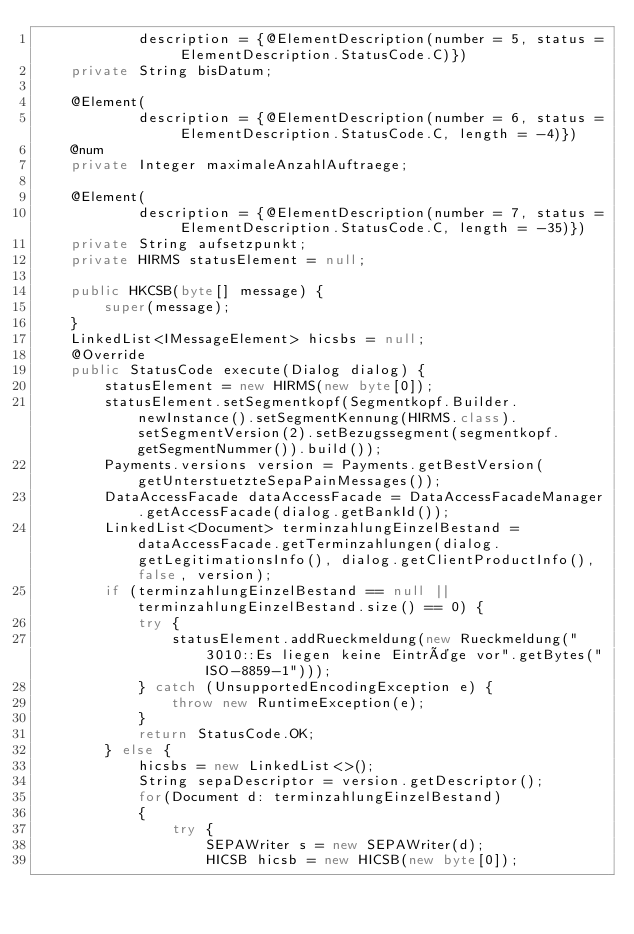<code> <loc_0><loc_0><loc_500><loc_500><_Java_>			description = {@ElementDescription(number = 5, status = ElementDescription.StatusCode.C)})
	private String bisDatum;

	@Element(
			description = {@ElementDescription(number = 6, status = ElementDescription.StatusCode.C, length = -4)})
	@num
	private Integer maximaleAnzahlAuftraege;

	@Element(
			description = {@ElementDescription(number = 7, status = ElementDescription.StatusCode.C, length = -35)})
	private String aufsetzpunkt;
	private HIRMS statusElement = null;

	public HKCSB(byte[] message) {
		super(message);
	}
	LinkedList<IMessageElement> hicsbs = null;
	@Override
	public StatusCode execute(Dialog dialog) {
		statusElement = new HIRMS(new byte[0]);
		statusElement.setSegmentkopf(Segmentkopf.Builder.newInstance().setSegmentKennung(HIRMS.class).setSegmentVersion(2).setBezugssegment(segmentkopf.getSegmentNummer()).build());
		Payments.versions version = Payments.getBestVersion(getUnterstuetzteSepaPainMessages());
		DataAccessFacade dataAccessFacade = DataAccessFacadeManager.getAccessFacade(dialog.getBankId());
		LinkedList<Document> terminzahlungEinzelBestand = dataAccessFacade.getTerminzahlungen(dialog.getLegitimationsInfo(), dialog.getClientProductInfo(),false, version);
		if (terminzahlungEinzelBestand == null || terminzahlungEinzelBestand.size() == 0) {
			try {
				statusElement.addRueckmeldung(new Rueckmeldung("3010::Es liegen keine Einträge vor".getBytes("ISO-8859-1")));
			} catch (UnsupportedEncodingException e) {
				throw new RuntimeException(e);
			}
			return StatusCode.OK;
		} else {
			hicsbs = new LinkedList<>();
			String sepaDescriptor = version.getDescriptor();
			for(Document d: terminzahlungEinzelBestand)
			{
				try {
					SEPAWriter s = new SEPAWriter(d);
					HICSB hicsb = new HICSB(new byte[0]);</code> 